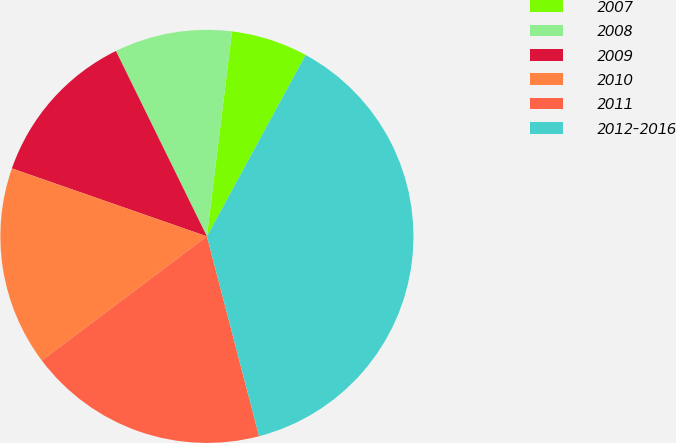Convert chart. <chart><loc_0><loc_0><loc_500><loc_500><pie_chart><fcel>2007<fcel>2008<fcel>2009<fcel>2010<fcel>2011<fcel>2012-2016<nl><fcel>5.99%<fcel>9.2%<fcel>12.4%<fcel>15.6%<fcel>18.8%<fcel>38.01%<nl></chart> 